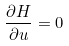Convert formula to latex. <formula><loc_0><loc_0><loc_500><loc_500>\frac { \partial H } { \partial u } = 0</formula> 